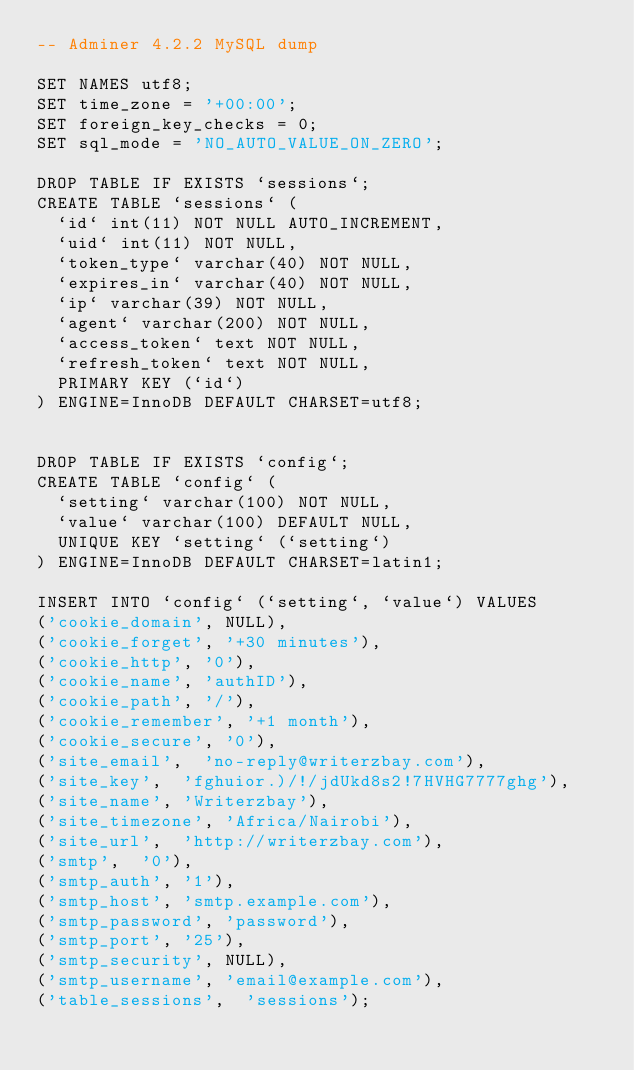Convert code to text. <code><loc_0><loc_0><loc_500><loc_500><_SQL_>-- Adminer 4.2.2 MySQL dump

SET NAMES utf8;
SET time_zone = '+00:00';
SET foreign_key_checks = 0;
SET sql_mode = 'NO_AUTO_VALUE_ON_ZERO';

DROP TABLE IF EXISTS `sessions`;
CREATE TABLE `sessions` (
  `id` int(11) NOT NULL AUTO_INCREMENT,
  `uid` int(11) NOT NULL,
  `token_type` varchar(40) NOT NULL,
  `expires_in` varchar(40) NOT NULL,
  `ip` varchar(39) NOT NULL,
  `agent` varchar(200) NOT NULL,
  `access_token` text NOT NULL,
  `refresh_token` text NOT NULL,
  PRIMARY KEY (`id`)
) ENGINE=InnoDB DEFAULT CHARSET=utf8;


DROP TABLE IF EXISTS `config`;
CREATE TABLE `config` (
  `setting` varchar(100) NOT NULL,
  `value` varchar(100) DEFAULT NULL,
  UNIQUE KEY `setting` (`setting`)
) ENGINE=InnoDB DEFAULT CHARSET=latin1;

INSERT INTO `config` (`setting`, `value`) VALUES
('cookie_domain', NULL),
('cookie_forget', '+30 minutes'),
('cookie_http', '0'),
('cookie_name', 'authID'),
('cookie_path', '/'),
('cookie_remember', '+1 month'),
('cookie_secure', '0'),
('site_email',  'no-reply@writerzbay.com'),
('site_key',  'fghuior.)/!/jdUkd8s2!7HVHG7777ghg'),
('site_name', 'Writerzbay'),
('site_timezone', 'Africa/Nairobi'),
('site_url',  'http://writerzbay.com'),
('smtp',  '0'),
('smtp_auth', '1'),
('smtp_host', 'smtp.example.com'),
('smtp_password', 'password'),
('smtp_port', '25'),
('smtp_security', NULL),
('smtp_username', 'email@example.com'),
('table_sessions',  'sessions');
</code> 